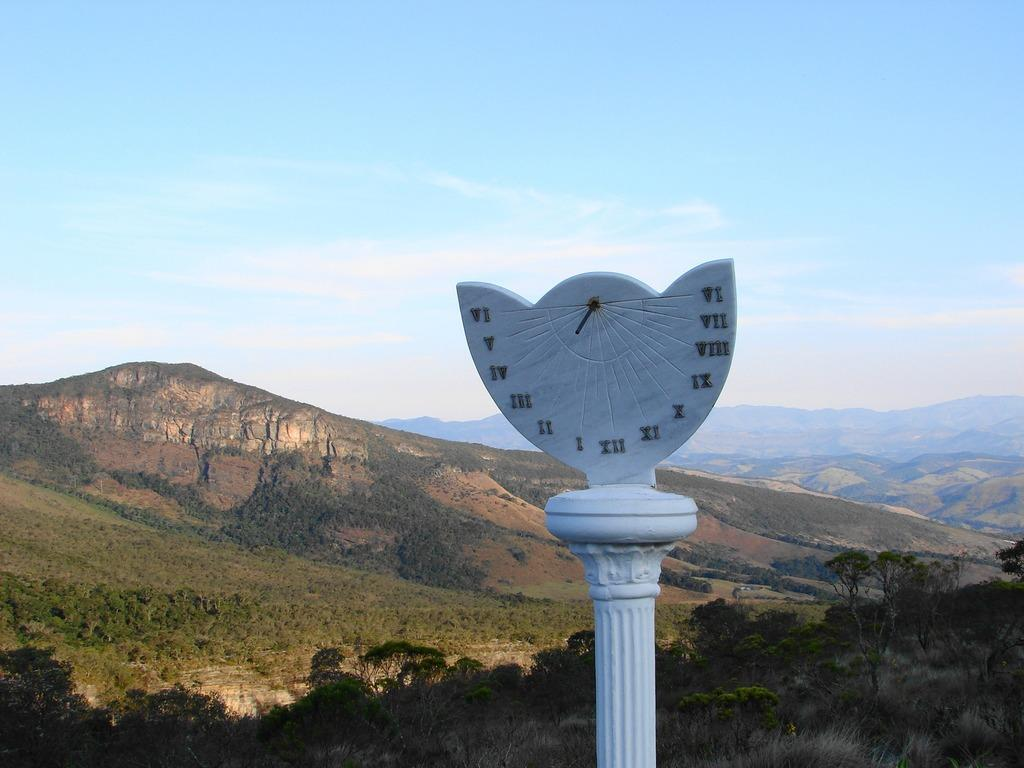What is the main object in the image? There is a white color pillar with numbers in the image. What can be seen in the background of the image? There are trees, hills, and the sky visible in the background of the image. What is the condition of the sky in the image? Clouds are present in the sky. What type of wine is being served on the sand in the image? There is no wine or sand present in the image. 